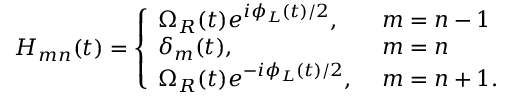<formula> <loc_0><loc_0><loc_500><loc_500>H _ { m n } ( t ) = \left \{ \begin{array} { l l } { \Omega _ { R } ( t ) e ^ { i \phi _ { L } ( t ) / 2 } , \ } & { m = n - 1 } \\ { \delta _ { m } ( t ) , \ } & { m = n } \\ { \Omega _ { R } ( t ) e ^ { - i \phi _ { L } ( t ) / 2 } , \ } & { m = n + 1 . } \end{array}</formula> 